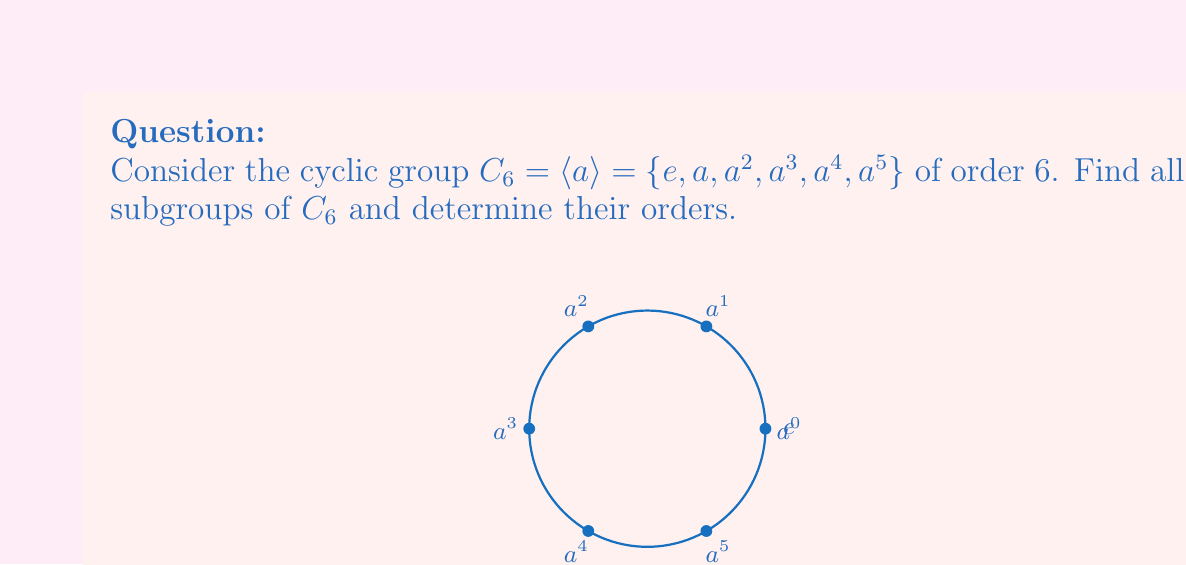Provide a solution to this math problem. To find all subgroups of $C_6$, we'll use the following steps:

1) Recall that the order of a subgroup must divide the order of the group. The divisors of 6 are 1, 2, 3, and 6.

2) For each divisor $d$, we'll look for elements of order $d$ in $C_6$:

   - Order 1: Only the identity element $e$ has order 1.
   - Order 2: $a^3$ has order 2 because $(a^3)^2 = a^6 = e$.
   - Order 3: $a^2$ and $a^4$ have order 3 because $(a^2)^3 = (a^4)^3 = e$.
   - Order 6: $a$ and $a^5$ have order 6.

3) Now, let's construct the subgroups:

   - $\{e\}$ is always a subgroup (the trivial subgroup).
   - $\langle a^3 \rangle = \{e, a^3\}$ is a subgroup of order 2.
   - $\langle a^2 \rangle = \{e, a^2, a^4\}$ is a subgroup of order 3.
   - $C_6$ itself is a subgroup of order 6.

4) We can verify that these are indeed all the subgroups:
   - Any subgroup containing $a$ or $a^5$ must be the entire group $C_6$.
   - The subgroup generated by $a^2$ is the same as the one generated by $a^4$.

Therefore, $C_6$ has four subgroups in total.
Answer: The subgroups of $C_6$ are: $\{e\}$ (order 1), $\{e, a^3\}$ (order 2), $\{e, a^2, a^4\}$ (order 3), and $C_6$ itself (order 6). 